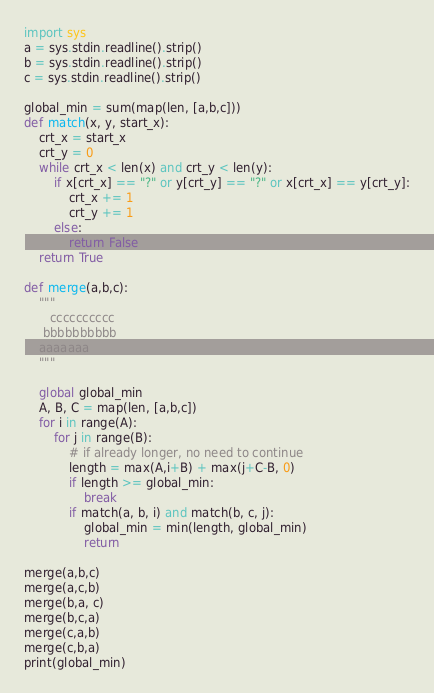<code> <loc_0><loc_0><loc_500><loc_500><_Python_>import sys
a = sys.stdin.readline().strip()
b = sys.stdin.readline().strip()
c = sys.stdin.readline().strip()

global_min = sum(map(len, [a,b,c]))
def match(x, y, start_x):
    crt_x = start_x
    crt_y = 0
    while crt_x < len(x) and crt_y < len(y):
        if x[crt_x] == "?" or y[crt_y] == "?" or x[crt_x] == y[crt_y]:
            crt_x += 1
            crt_y += 1
        else:
            return False
    return True

def merge(a,b,c):
    """
       cccccccccc
     bbbbbbbbbb
    aaaaaaa
    """
    
    global global_min
    A, B, C = map(len, [a,b,c])
    for i in range(A):
        for j in range(B):
            # if already longer, no need to continue
            length = max(A,i+B) + max(j+C-B, 0)
            if length >= global_min:
                break
            if match(a, b, i) and match(b, c, j):
                global_min = min(length, global_min)
                return

merge(a,b,c)
merge(a,c,b)
merge(b,a, c)
merge(b,c,a)
merge(c,a,b)
merge(c,b,a)
print(global_min)</code> 